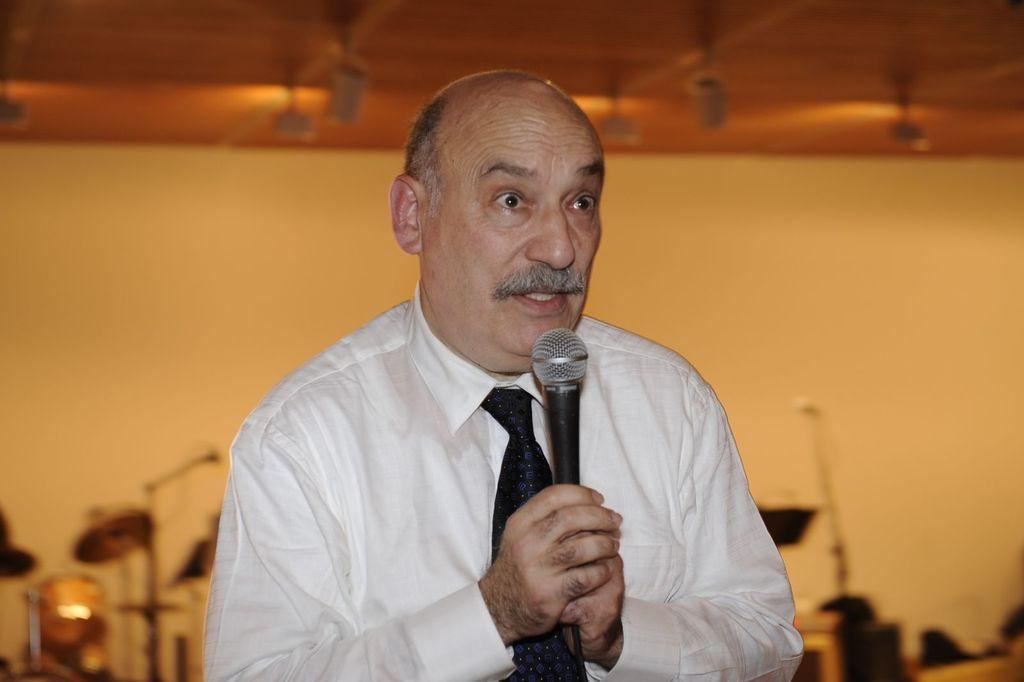What is the man in the image doing? The man is speaking into a microphone. What is the man wearing on his upper body? The man is wearing a shirt and a tie. How many rabbits can be seen in the image? There are no rabbits present in the image. What type of education does the man have, as indicated by the image? The image does not provide any information about the man's education. 